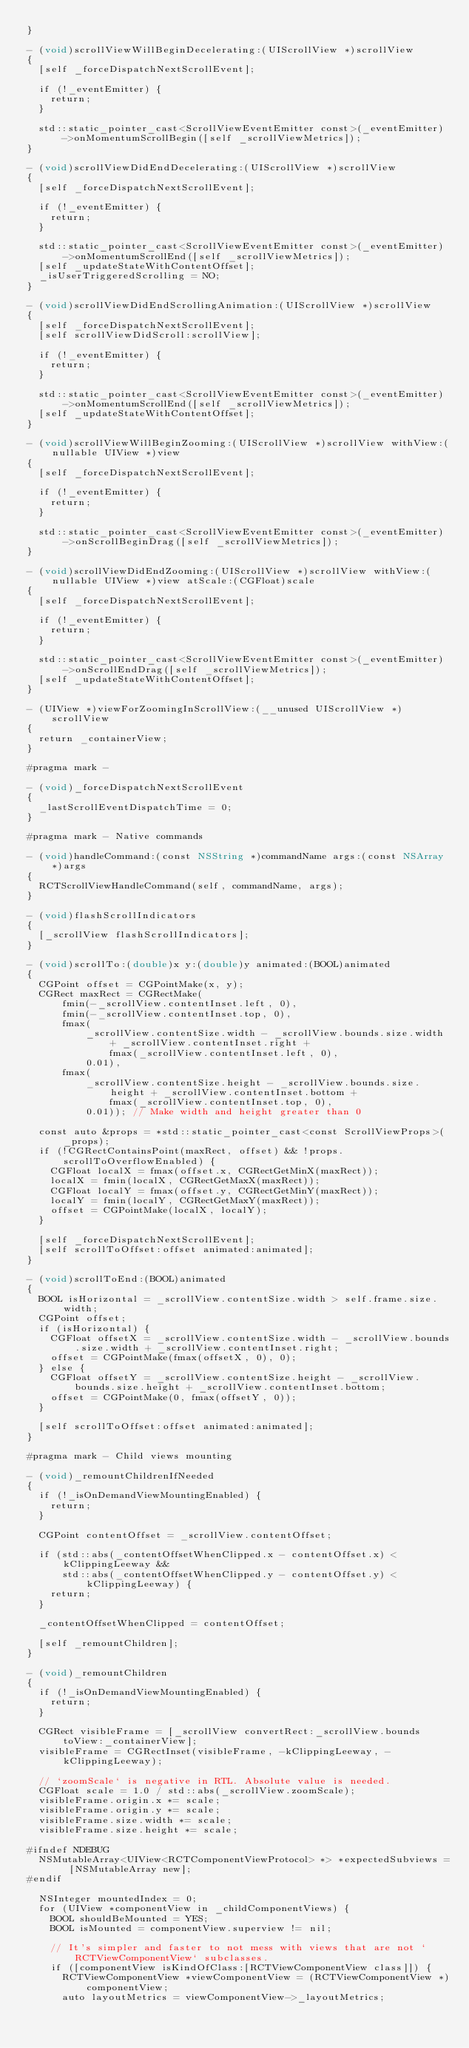<code> <loc_0><loc_0><loc_500><loc_500><_ObjectiveC_>}

- (void)scrollViewWillBeginDecelerating:(UIScrollView *)scrollView
{
  [self _forceDispatchNextScrollEvent];

  if (!_eventEmitter) {
    return;
  }

  std::static_pointer_cast<ScrollViewEventEmitter const>(_eventEmitter)
      ->onMomentumScrollBegin([self _scrollViewMetrics]);
}

- (void)scrollViewDidEndDecelerating:(UIScrollView *)scrollView
{
  [self _forceDispatchNextScrollEvent];

  if (!_eventEmitter) {
    return;
  }

  std::static_pointer_cast<ScrollViewEventEmitter const>(_eventEmitter)->onMomentumScrollEnd([self _scrollViewMetrics]);
  [self _updateStateWithContentOffset];
  _isUserTriggeredScrolling = NO;
}

- (void)scrollViewDidEndScrollingAnimation:(UIScrollView *)scrollView
{
  [self _forceDispatchNextScrollEvent];
  [self scrollViewDidScroll:scrollView];

  if (!_eventEmitter) {
    return;
  }

  std::static_pointer_cast<ScrollViewEventEmitter const>(_eventEmitter)->onMomentumScrollEnd([self _scrollViewMetrics]);
  [self _updateStateWithContentOffset];
}

- (void)scrollViewWillBeginZooming:(UIScrollView *)scrollView withView:(nullable UIView *)view
{
  [self _forceDispatchNextScrollEvent];

  if (!_eventEmitter) {
    return;
  }

  std::static_pointer_cast<ScrollViewEventEmitter const>(_eventEmitter)->onScrollBeginDrag([self _scrollViewMetrics]);
}

- (void)scrollViewDidEndZooming:(UIScrollView *)scrollView withView:(nullable UIView *)view atScale:(CGFloat)scale
{
  [self _forceDispatchNextScrollEvent];

  if (!_eventEmitter) {
    return;
  }

  std::static_pointer_cast<ScrollViewEventEmitter const>(_eventEmitter)->onScrollEndDrag([self _scrollViewMetrics]);
  [self _updateStateWithContentOffset];
}

- (UIView *)viewForZoomingInScrollView:(__unused UIScrollView *)scrollView
{
  return _containerView;
}

#pragma mark -

- (void)_forceDispatchNextScrollEvent
{
  _lastScrollEventDispatchTime = 0;
}

#pragma mark - Native commands

- (void)handleCommand:(const NSString *)commandName args:(const NSArray *)args
{
  RCTScrollViewHandleCommand(self, commandName, args);
}

- (void)flashScrollIndicators
{
  [_scrollView flashScrollIndicators];
}

- (void)scrollTo:(double)x y:(double)y animated:(BOOL)animated
{
  CGPoint offset = CGPointMake(x, y);
  CGRect maxRect = CGRectMake(
      fmin(-_scrollView.contentInset.left, 0),
      fmin(-_scrollView.contentInset.top, 0),
      fmax(
          _scrollView.contentSize.width - _scrollView.bounds.size.width + _scrollView.contentInset.right +
              fmax(_scrollView.contentInset.left, 0),
          0.01),
      fmax(
          _scrollView.contentSize.height - _scrollView.bounds.size.height + _scrollView.contentInset.bottom +
              fmax(_scrollView.contentInset.top, 0),
          0.01)); // Make width and height greater than 0

  const auto &props = *std::static_pointer_cast<const ScrollViewProps>(_props);
  if (!CGRectContainsPoint(maxRect, offset) && !props.scrollToOverflowEnabled) {
    CGFloat localX = fmax(offset.x, CGRectGetMinX(maxRect));
    localX = fmin(localX, CGRectGetMaxX(maxRect));
    CGFloat localY = fmax(offset.y, CGRectGetMinY(maxRect));
    localY = fmin(localY, CGRectGetMaxY(maxRect));
    offset = CGPointMake(localX, localY);
  }

  [self _forceDispatchNextScrollEvent];
  [self scrollToOffset:offset animated:animated];
}

- (void)scrollToEnd:(BOOL)animated
{
  BOOL isHorizontal = _scrollView.contentSize.width > self.frame.size.width;
  CGPoint offset;
  if (isHorizontal) {
    CGFloat offsetX = _scrollView.contentSize.width - _scrollView.bounds.size.width + _scrollView.contentInset.right;
    offset = CGPointMake(fmax(offsetX, 0), 0);
  } else {
    CGFloat offsetY = _scrollView.contentSize.height - _scrollView.bounds.size.height + _scrollView.contentInset.bottom;
    offset = CGPointMake(0, fmax(offsetY, 0));
  }

  [self scrollToOffset:offset animated:animated];
}

#pragma mark - Child views mounting

- (void)_remountChildrenIfNeeded
{
  if (!_isOnDemandViewMountingEnabled) {
    return;
  }

  CGPoint contentOffset = _scrollView.contentOffset;

  if (std::abs(_contentOffsetWhenClipped.x - contentOffset.x) < kClippingLeeway &&
      std::abs(_contentOffsetWhenClipped.y - contentOffset.y) < kClippingLeeway) {
    return;
  }

  _contentOffsetWhenClipped = contentOffset;

  [self _remountChildren];
}

- (void)_remountChildren
{
  if (!_isOnDemandViewMountingEnabled) {
    return;
  }

  CGRect visibleFrame = [_scrollView convertRect:_scrollView.bounds toView:_containerView];
  visibleFrame = CGRectInset(visibleFrame, -kClippingLeeway, -kClippingLeeway);

  // `zoomScale` is negative in RTL. Absolute value is needed.
  CGFloat scale = 1.0 / std::abs(_scrollView.zoomScale);
  visibleFrame.origin.x *= scale;
  visibleFrame.origin.y *= scale;
  visibleFrame.size.width *= scale;
  visibleFrame.size.height *= scale;

#ifndef NDEBUG
  NSMutableArray<UIView<RCTComponentViewProtocol> *> *expectedSubviews = [NSMutableArray new];
#endif

  NSInteger mountedIndex = 0;
  for (UIView *componentView in _childComponentViews) {
    BOOL shouldBeMounted = YES;
    BOOL isMounted = componentView.superview != nil;

    // It's simpler and faster to not mess with views that are not `RCTViewComponentView` subclasses.
    if ([componentView isKindOfClass:[RCTViewComponentView class]]) {
      RCTViewComponentView *viewComponentView = (RCTViewComponentView *)componentView;
      auto layoutMetrics = viewComponentView->_layoutMetrics;
</code> 